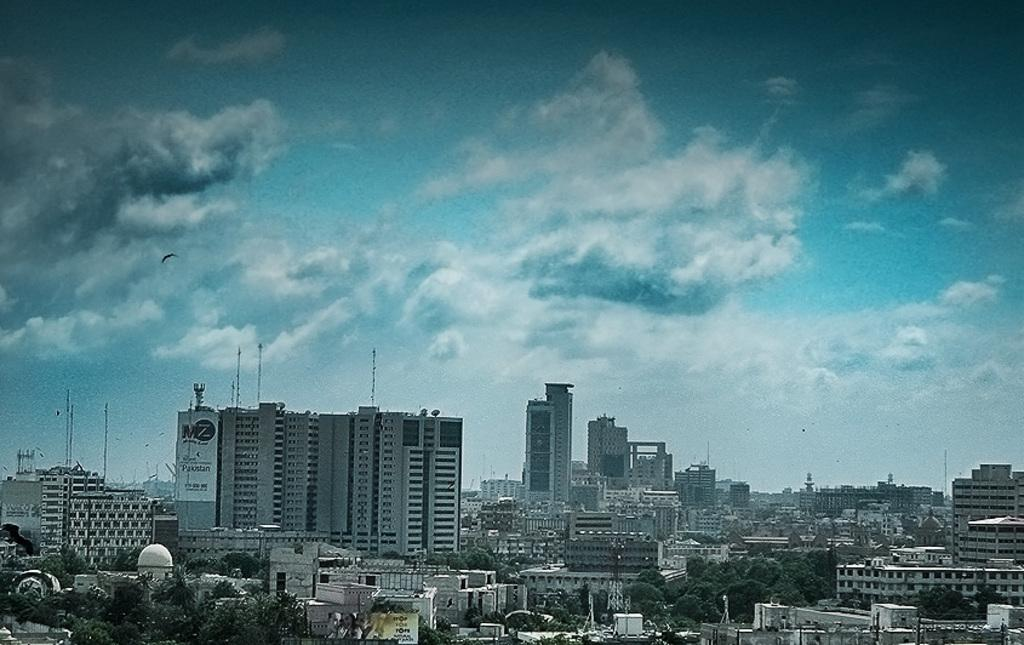What type of structures can be seen in the image? There is a group of buildings in the image. What other natural elements are present in the image? There are trees in the image. Are there any man-made objects besides the buildings? Yes, there are poles in the image. What can be seen in the background of the image? The sky is visible in the background of the image, and clouds are present in the sky. What type of loaf is being used to polish the buildings in the image? There is no loaf present in the image, and the buildings are not being polished. 